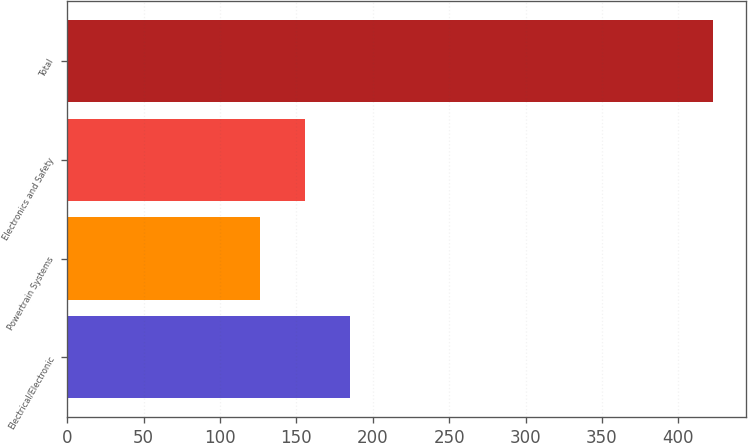Convert chart. <chart><loc_0><loc_0><loc_500><loc_500><bar_chart><fcel>Electrical/Electronic<fcel>Powertrain Systems<fcel>Electronics and Safety<fcel>Total<nl><fcel>185.4<fcel>126<fcel>155.7<fcel>423<nl></chart> 